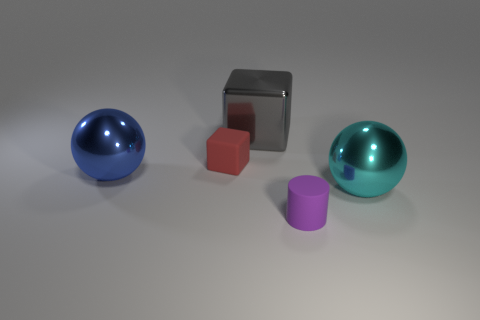There is a small rubber object in front of the tiny rubber object behind the blue sphere; what shape is it?
Your answer should be compact. Cylinder. Are there fewer cyan objects that are in front of the cylinder than brown metal spheres?
Give a very brief answer. No. What number of cubes are the same size as the purple cylinder?
Make the answer very short. 1. There is a small rubber object left of the gray block; what shape is it?
Ensure brevity in your answer.  Cube. Is the number of cyan metallic objects less than the number of large purple matte things?
Provide a succinct answer. No. There is a sphere left of the purple matte thing; how big is it?
Make the answer very short. Large. Is the number of big gray things greater than the number of big objects?
Your response must be concise. No. What is the tiny red object made of?
Offer a terse response. Rubber. How many other things are there of the same material as the small red block?
Offer a very short reply. 1. What number of small metallic blocks are there?
Make the answer very short. 0. 